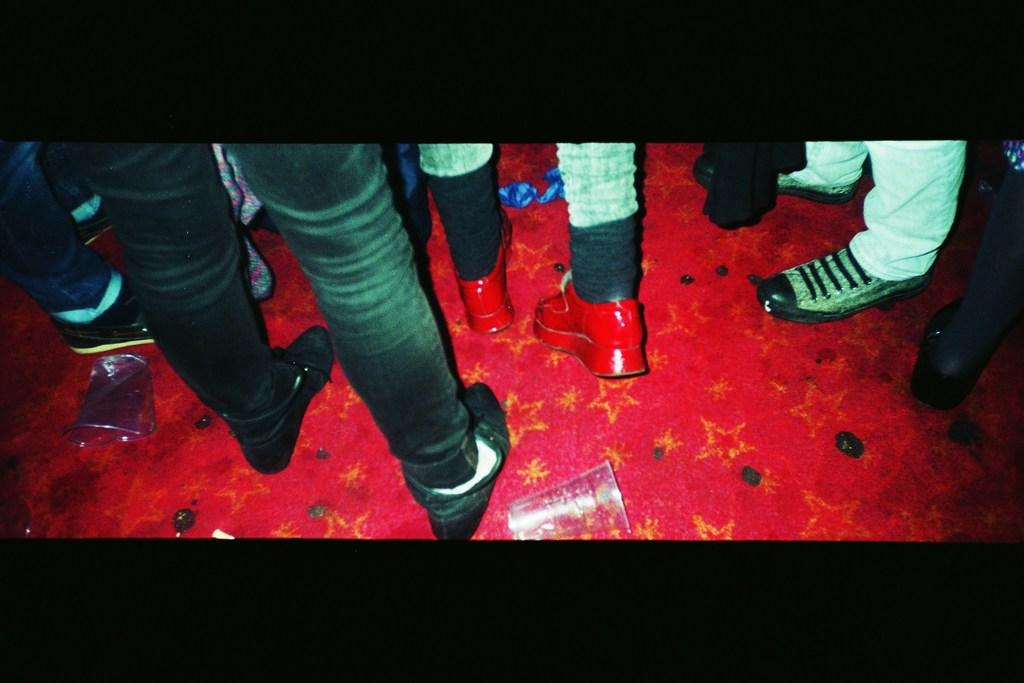What can be seen in the image involving people? There are people standing in the image. What are the people wearing on their feet? The people are wearing shoes. What is the color of the floor in the image? The floor is red in color. What objects are on the floor in the image? There are glasses on the floor. How does the sponge help the people in the image? There is no sponge present in the image, so it cannot help the people in any way. 